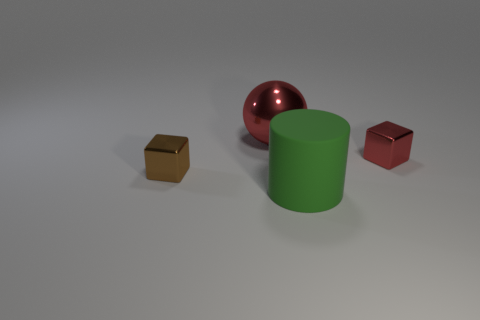What is the color of the big sphere that is the same material as the tiny red cube?
Offer a very short reply. Red. There is a green matte thing; is its size the same as the metal cube that is left of the big ball?
Ensure brevity in your answer.  No. There is a cube that is behind the tiny brown shiny cube in front of the big ball that is behind the brown cube; what is its size?
Offer a very short reply. Small. What number of matte objects are either green cylinders or green blocks?
Your response must be concise. 1. What color is the metallic object in front of the tiny red metal cube?
Ensure brevity in your answer.  Brown. What shape is the object that is the same size as the brown shiny block?
Offer a very short reply. Cube. There is a large cylinder; does it have the same color as the tiny metal object that is on the left side of the large red metal thing?
Keep it short and to the point. No. What number of things are either things that are right of the large metallic object or large things in front of the brown thing?
Your answer should be compact. 2. There is a red object that is the same size as the green cylinder; what is its material?
Ensure brevity in your answer.  Metal. How many other objects are the same material as the cylinder?
Give a very brief answer. 0. 